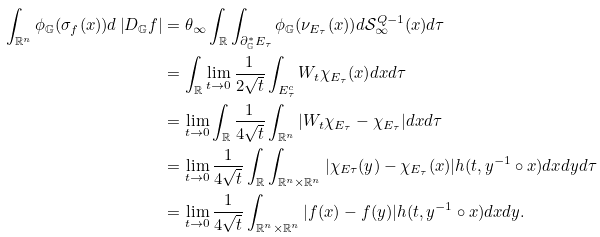<formula> <loc_0><loc_0><loc_500><loc_500>\int _ { { \mathbb { R } } ^ { n } } \phi _ { \mathbb { G } } ( \sigma _ { f } ( x ) ) d \left | D _ { \mathbb { G } } f \right | & = \theta _ { \infty } \int _ { \mathbb { R } } \int _ { \partial _ { \mathbb { G } } ^ { \ast } E _ { \tau } } \phi _ { \mathbb { G } } ( \nu _ { E _ { \tau } } ( x ) ) d { \mathcal { S } } _ { \infty } ^ { Q - 1 } ( x ) d \tau \\ & = \int _ { \mathbb { R } } \lim _ { t \rightarrow 0 } \frac { 1 } { 2 \sqrt { t } } \int _ { E _ { \tau } ^ { c } } W _ { t } \chi _ { E _ { \tau } } ( x ) d x d \tau \\ & = \lim _ { t \rightarrow 0 } \int _ { \mathbb { R } } \frac { 1 } { 4 \sqrt { t } } \int _ { \mathbb { R } ^ { n } } | W _ { t } \chi _ { E _ { \tau } } - \chi _ { E _ { \tau } } | d x d \tau \\ & = \lim _ { t \rightarrow 0 } \frac { 1 } { 4 \sqrt { t } } \int _ { \mathbb { R } } \int _ { \mathbb { R } ^ { n } \times \mathbb { R } ^ { n } } | \chi _ { E \tau } ( y ) - \chi _ { E _ { \tau } } ( x ) | h ( t , y ^ { - 1 } \circ x ) d x d y d \tau \\ & = \lim _ { t \rightarrow 0 } \frac { 1 } { 4 \sqrt { t } } \int _ { \mathbb { R } ^ { n } \times \mathbb { R } ^ { n } } | f ( x ) - f ( y ) | h ( t , y ^ { - 1 } \circ x ) d x d y .</formula> 